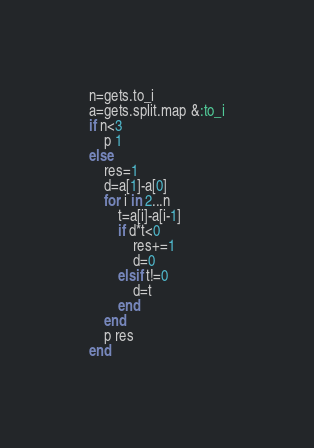<code> <loc_0><loc_0><loc_500><loc_500><_Ruby_>n=gets.to_i
a=gets.split.map &:to_i
if n<3
    p 1
else
    res=1
    d=a[1]-a[0]
    for i in 2...n
        t=a[i]-a[i-1]
        if d*t<0
            res+=1
            d=0
        elsif t!=0
            d=t
        end
    end
    p res
end
</code> 